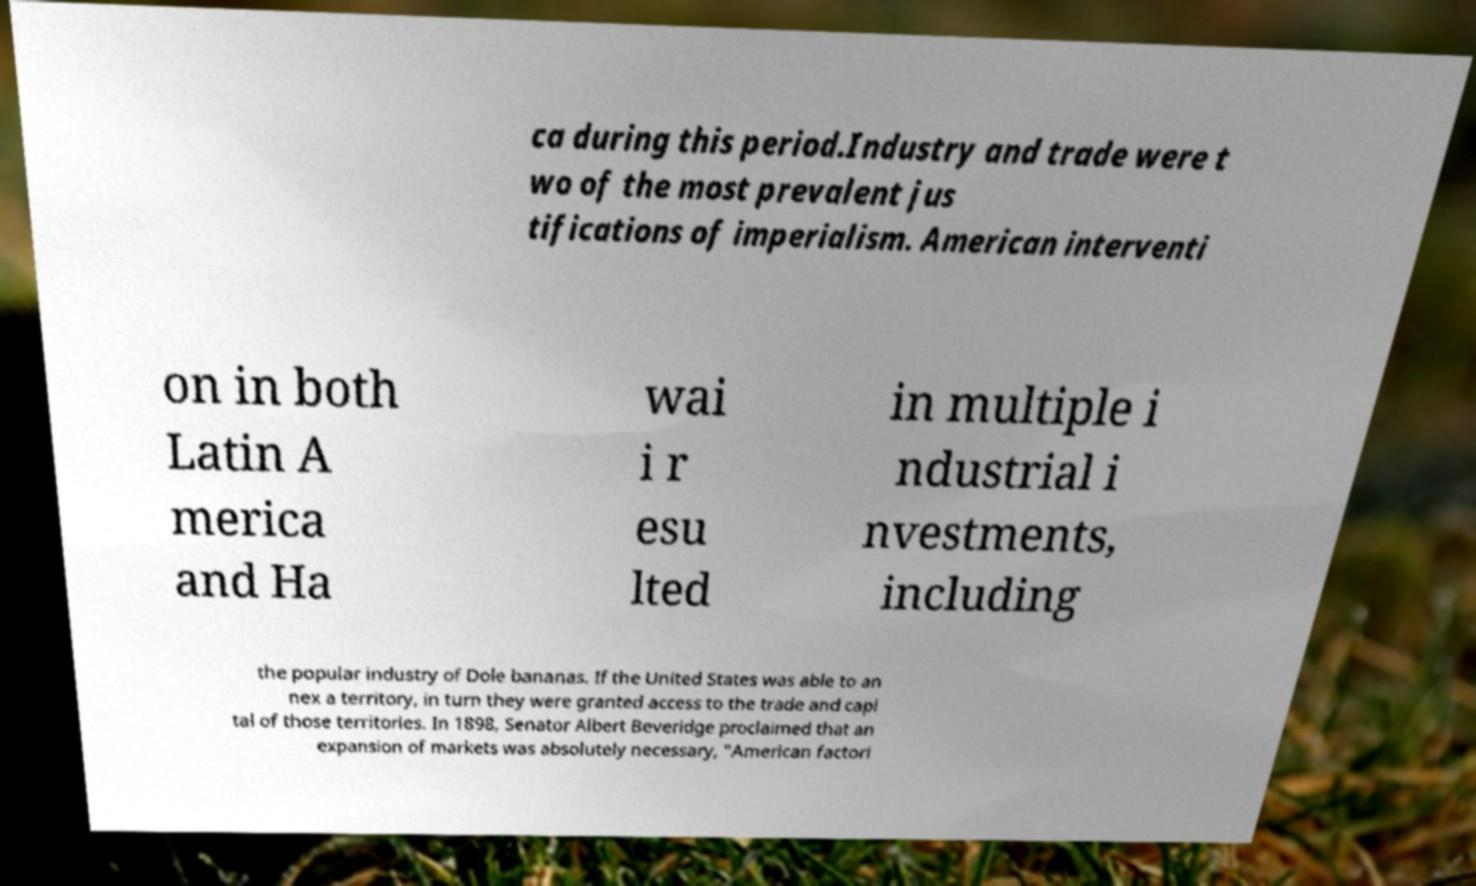Could you extract and type out the text from this image? ca during this period.Industry and trade were t wo of the most prevalent jus tifications of imperialism. American interventi on in both Latin A merica and Ha wai i r esu lted in multiple i ndustrial i nvestments, including the popular industry of Dole bananas. If the United States was able to an nex a territory, in turn they were granted access to the trade and capi tal of those territories. In 1898, Senator Albert Beveridge proclaimed that an expansion of markets was absolutely necessary, "American factori 